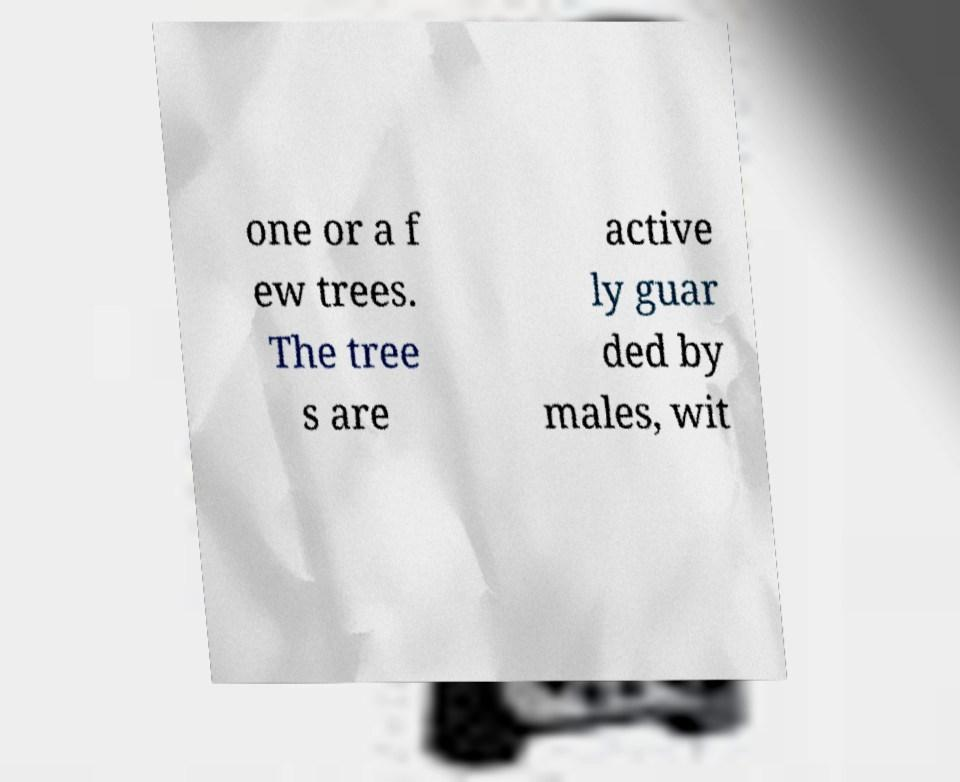For documentation purposes, I need the text within this image transcribed. Could you provide that? one or a f ew trees. The tree s are active ly guar ded by males, wit 